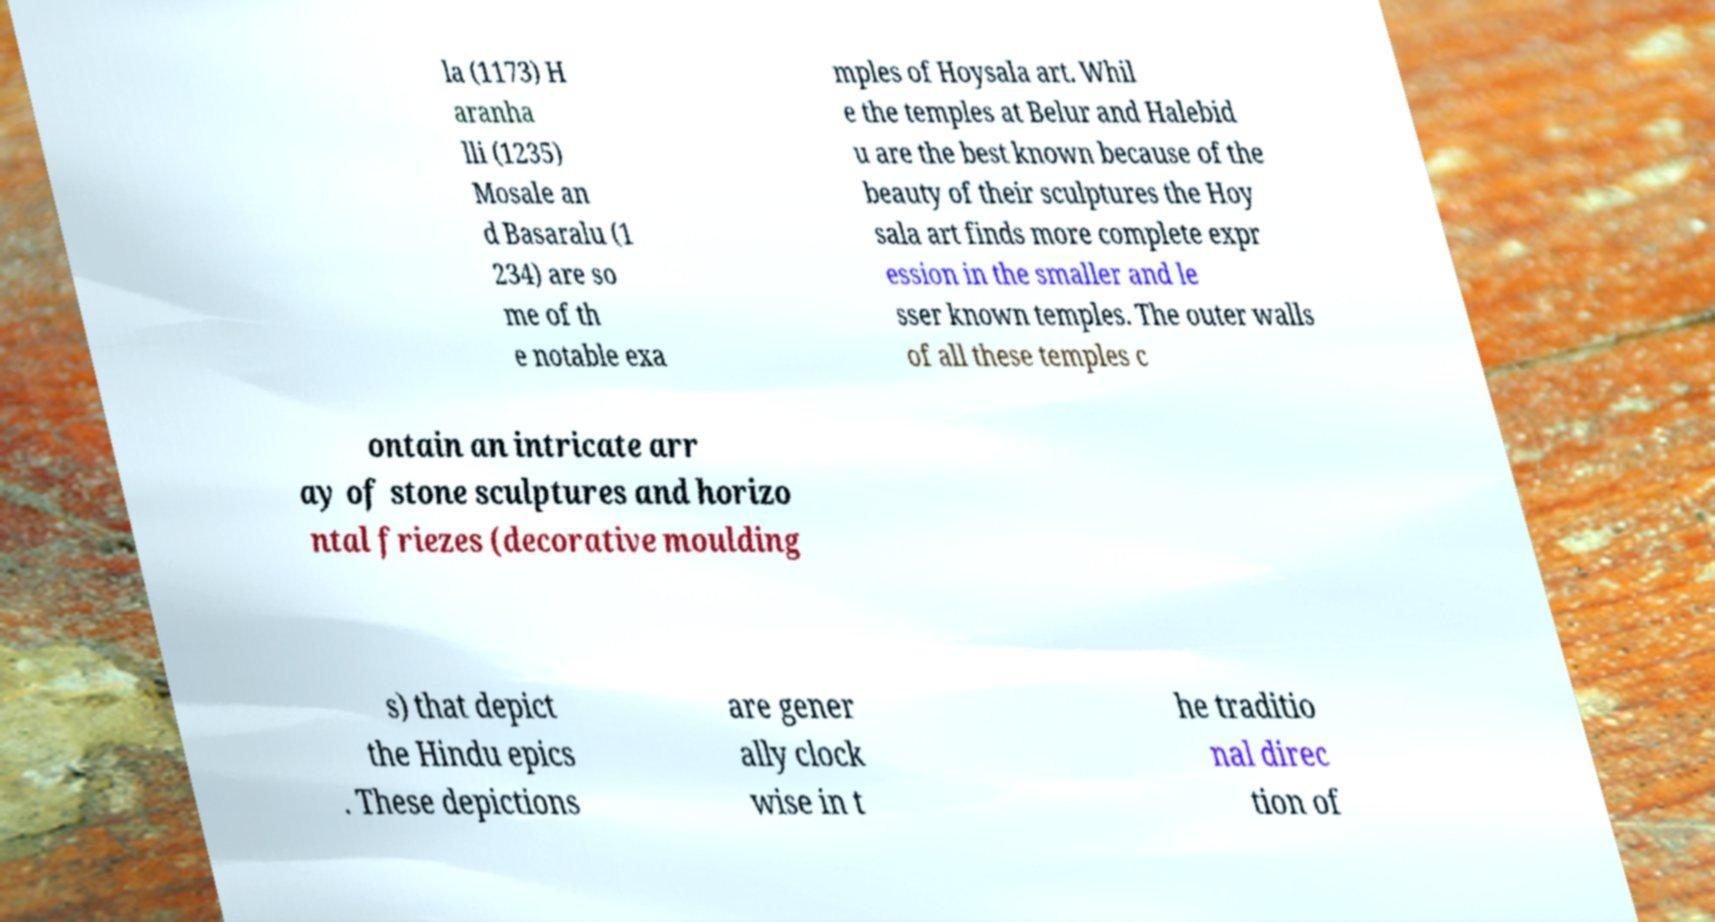Can you read and provide the text displayed in the image?This photo seems to have some interesting text. Can you extract and type it out for me? la (1173) H aranha lli (1235) Mosale an d Basaralu (1 234) are so me of th e notable exa mples of Hoysala art. Whil e the temples at Belur and Halebid u are the best known because of the beauty of their sculptures the Hoy sala art finds more complete expr ession in the smaller and le sser known temples. The outer walls of all these temples c ontain an intricate arr ay of stone sculptures and horizo ntal friezes (decorative moulding s) that depict the Hindu epics . These depictions are gener ally clock wise in t he traditio nal direc tion of 